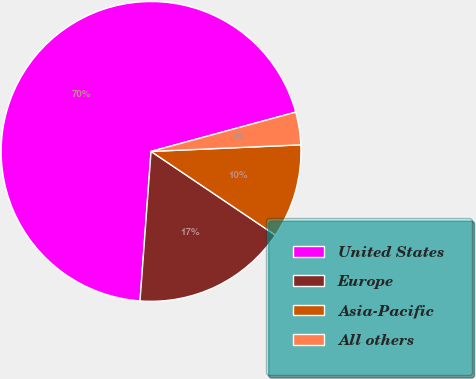Convert chart. <chart><loc_0><loc_0><loc_500><loc_500><pie_chart><fcel>United States<fcel>Europe<fcel>Asia-Pacific<fcel>All others<nl><fcel>69.6%<fcel>16.74%<fcel>10.13%<fcel>3.52%<nl></chart> 